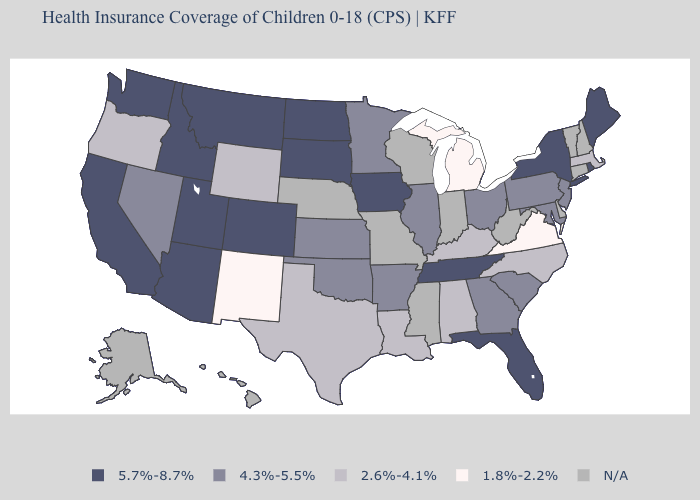Does New Mexico have the lowest value in the USA?
Concise answer only. Yes. Among the states that border Arizona , which have the lowest value?
Concise answer only. New Mexico. Name the states that have a value in the range 2.6%-4.1%?
Keep it brief. Alabama, Kentucky, Louisiana, Massachusetts, North Carolina, Oregon, Texas, Wyoming. Does the map have missing data?
Write a very short answer. Yes. Among the states that border South Carolina , which have the lowest value?
Write a very short answer. North Carolina. What is the highest value in the USA?
Be succinct. 5.7%-8.7%. Which states have the highest value in the USA?
Quick response, please. Arizona, California, Colorado, Florida, Idaho, Iowa, Maine, Montana, New York, North Dakota, Rhode Island, South Dakota, Tennessee, Utah, Washington. Does the map have missing data?
Answer briefly. Yes. Which states have the lowest value in the USA?
Concise answer only. Michigan, New Mexico, Virginia. What is the value of Oregon?
Be succinct. 2.6%-4.1%. Among the states that border Nebraska , which have the lowest value?
Write a very short answer. Wyoming. Does Massachusetts have the highest value in the USA?
Keep it brief. No. What is the highest value in the USA?
Write a very short answer. 5.7%-8.7%. What is the value of Kansas?
Quick response, please. 4.3%-5.5%. 